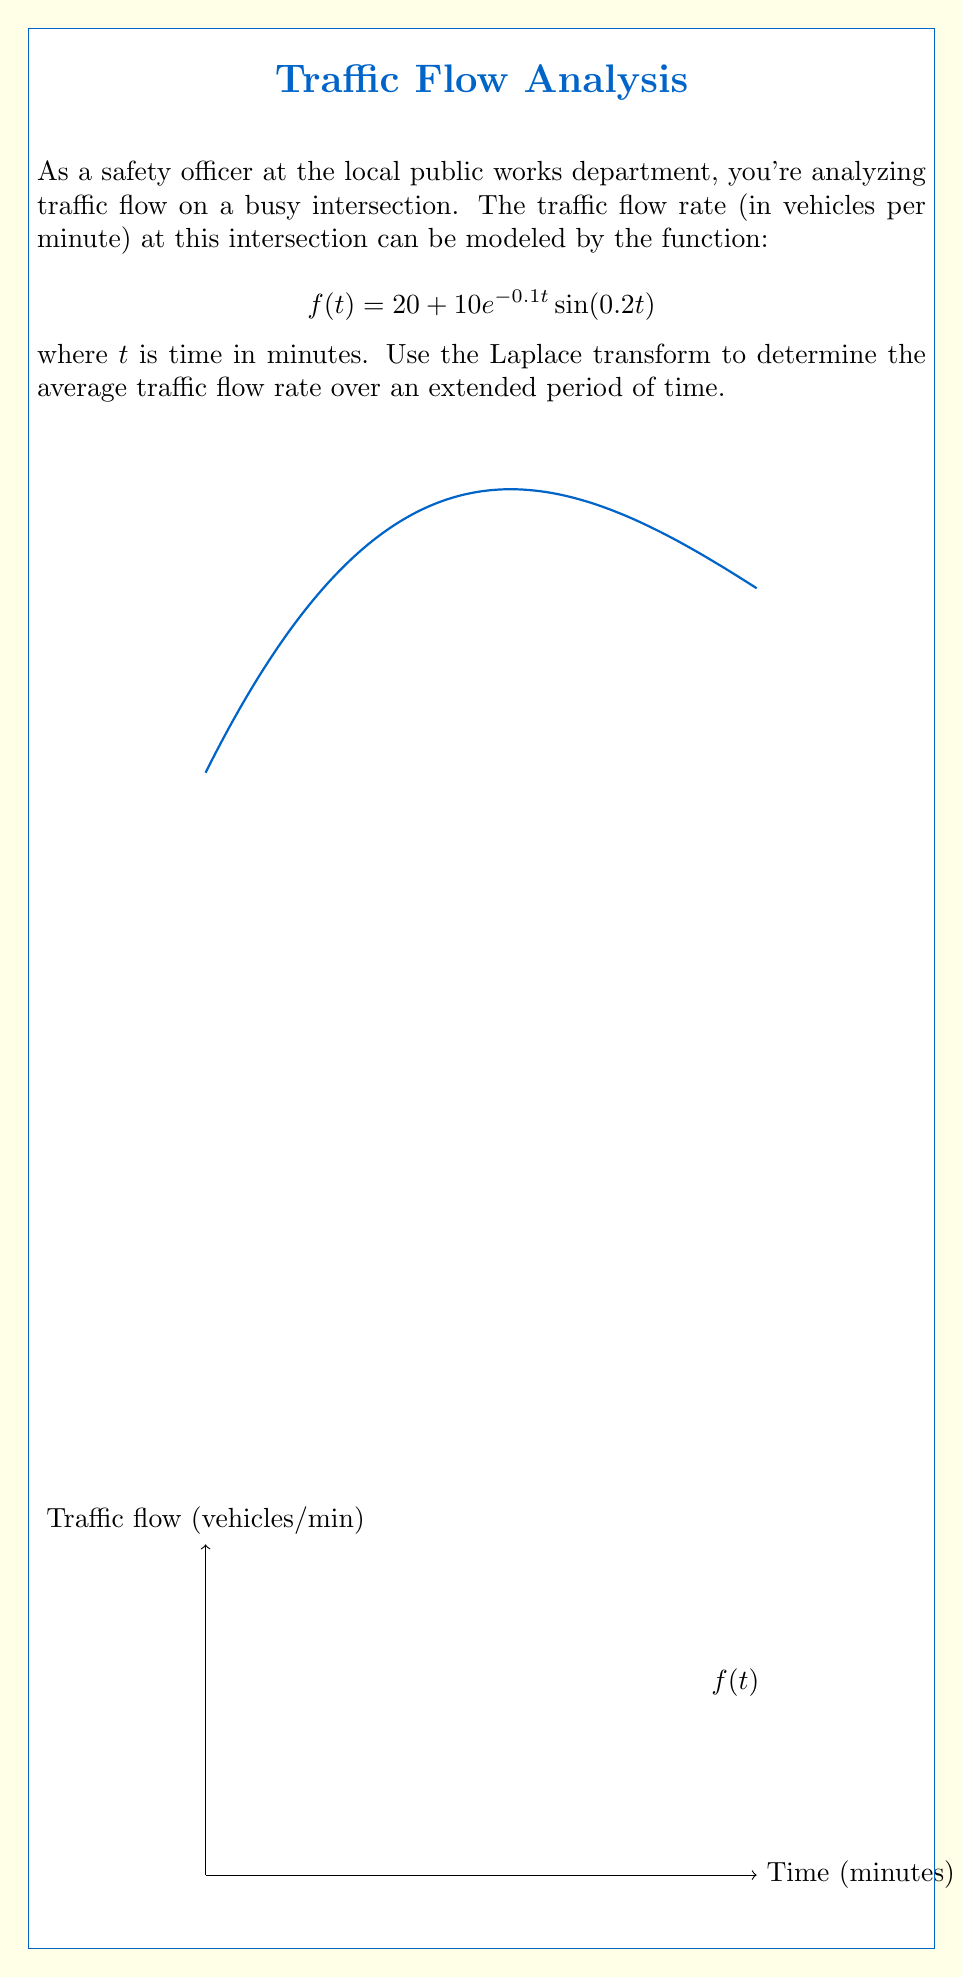Can you answer this question? Let's approach this step-by-step using the Laplace transform:

1) The Laplace transform of $f(t)$ is given by:
   $$F(s) = \mathcal{L}\{f(t)\} = \int_0^\infty f(t)e^{-st}dt$$

2) For our function $f(t) = 20 + 10e^{-0.1t}\sin(0.2t)$, we can split it into two parts:
   $$F(s) = \mathcal{L}\{20\} + \mathcal{L}\{10e^{-0.1t}\sin(0.2t)\}$$

3) The Laplace transform of a constant is given by $\mathcal{L}\{k\} = \frac{k}{s}$, so:
   $$\mathcal{L}\{20\} = \frac{20}{s}$$

4) For the second part, we can use the Laplace transform of a damped sinusoid:
   $$\mathcal{L}\{e^{-at}\sin(bt)\} = \frac{b}{(s+a)^2 + b^2}$$

   Here, $a = 0.1$ and $b = 0.2$, and we have a factor of 10, so:
   $$\mathcal{L}\{10e^{-0.1t}\sin(0.2t)\} = \frac{2}{(s+0.1)^2 + 0.04}$$

5) Combining these results:
   $$F(s) = \frac{20}{s} + \frac{2}{(s+0.1)^2 + 0.04}$$

6) To find the average traffic flow rate over an extended period, we need to find the limit of $f(t)$ as $t$ approaches infinity. In the s-domain, this is equivalent to finding $\lim_{s \to 0} sF(s)$:

   $$\lim_{s \to 0} sF(s) = \lim_{s \to 0} \left(20 + \frac{2s}{(s+0.1)^2 + 0.04}\right)$$

7) As $s$ approaches 0, the second term approaches 0, leaving us with:
   $$\lim_{s \to 0} sF(s) = 20$$

Therefore, the average traffic flow rate over an extended period of time is 20 vehicles per minute.
Answer: 20 vehicles per minute 